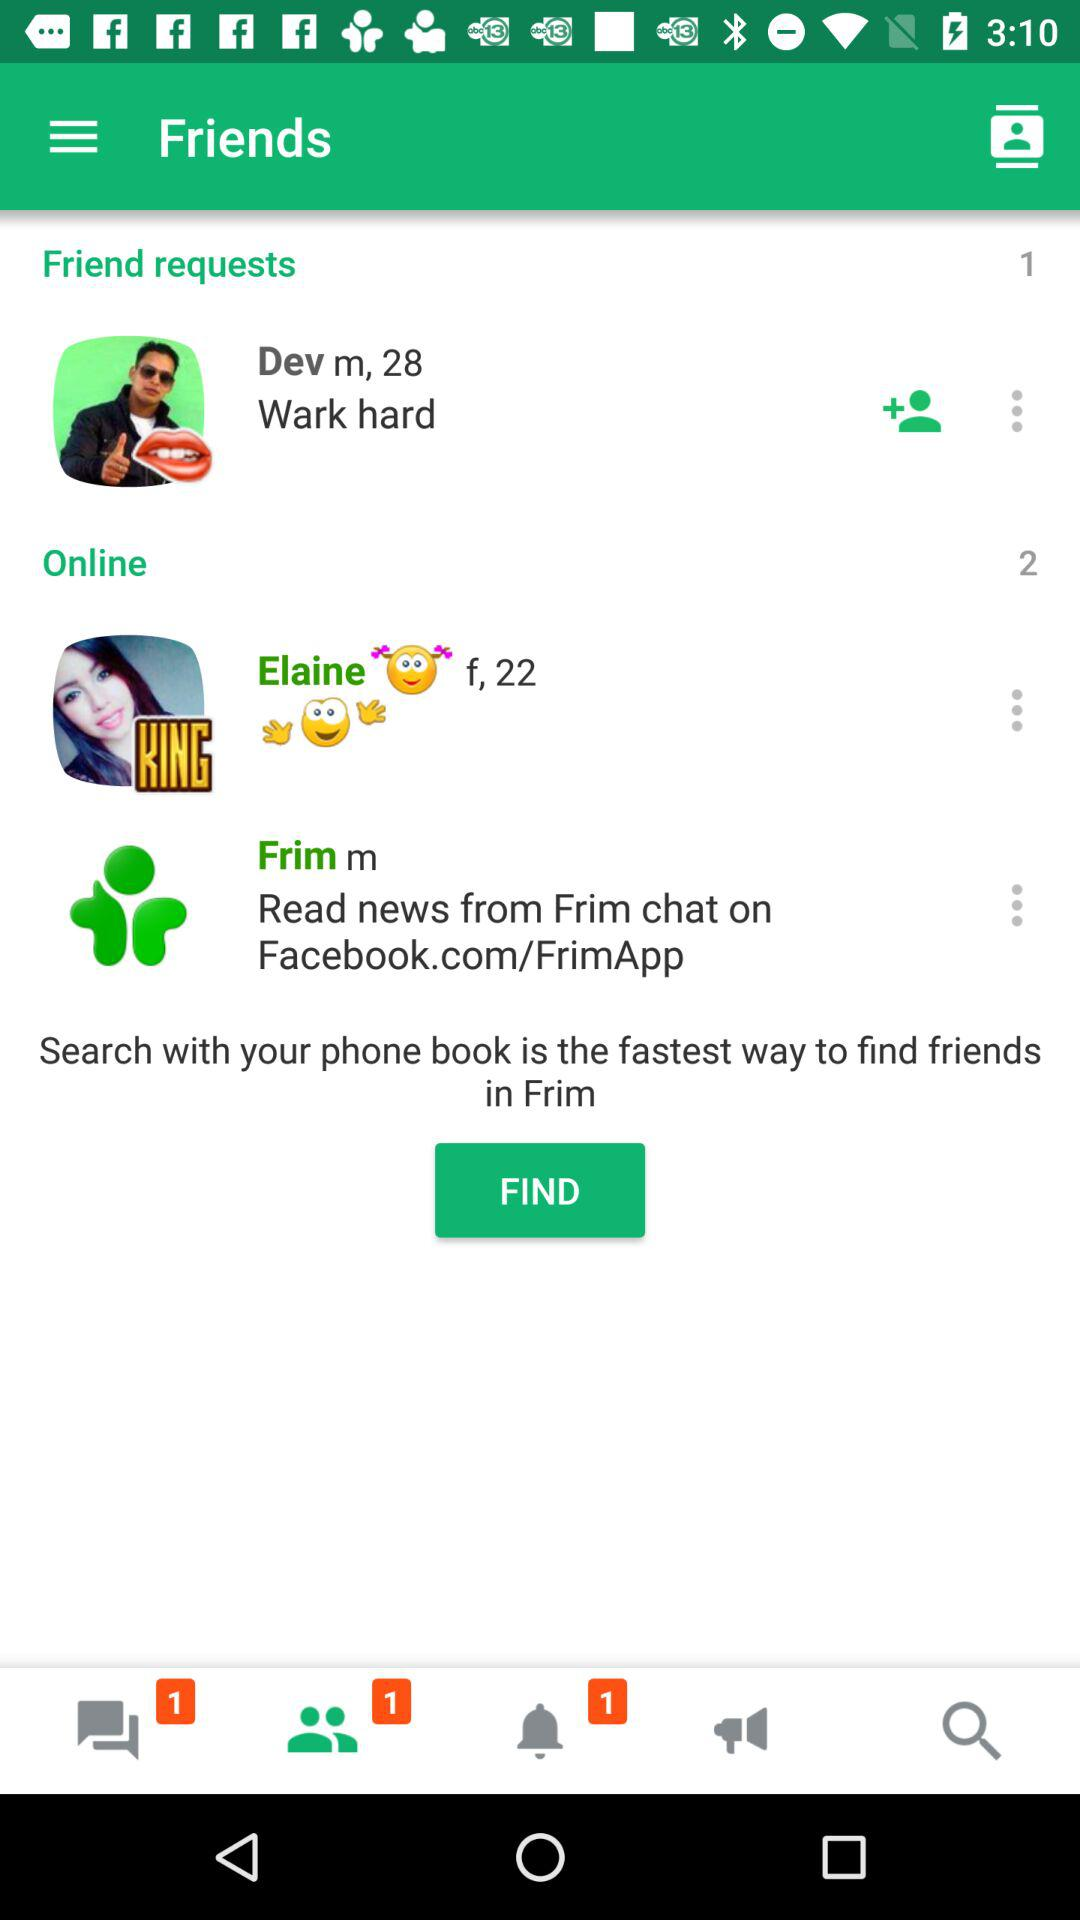How many people are online? There are 2 people online. 